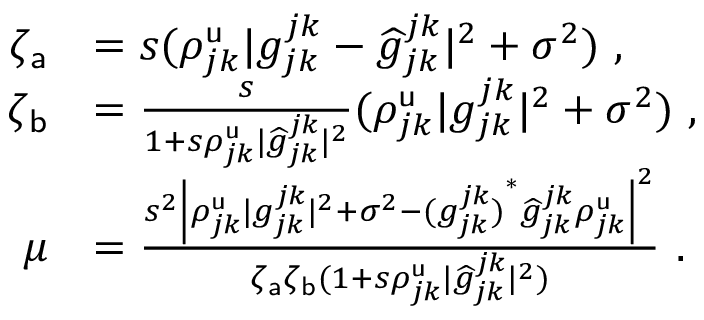Convert formula to latex. <formula><loc_0><loc_0><loc_500><loc_500>\begin{array} { r l } { \zeta _ { a } } & { = s ( \rho _ { j k } ^ { u } | g _ { j k } ^ { j k } - \widehat { g } _ { j k } ^ { j k } | ^ { 2 } + \sigma ^ { 2 } ) \ , } \\ { \zeta _ { b } } & { = \frac { s } { 1 + s \rho _ { j k } ^ { u } | \widehat { g } _ { j k } ^ { j k } | ^ { 2 } } ( \rho _ { j k } ^ { u } | g _ { j k } ^ { j k } | ^ { 2 } + \sigma ^ { 2 } ) \ , } \\ { \mu } & { = \frac { s ^ { 2 } \left | { \rho _ { j k } ^ { u } | g _ { j k } ^ { j k } | ^ { 2 } + \sigma ^ { 2 } - { ( g _ { j k } ^ { j k } ) } ^ { \ast } \widehat { g } _ { j k } ^ { j k } \rho _ { j k } ^ { u } } \right | ^ { 2 } } { \zeta _ { a } \zeta _ { b } ( 1 + s \rho _ { j k } ^ { u } | \widehat { g } _ { j k } ^ { j k } | ^ { 2 } ) } \ . } \end{array}</formula> 